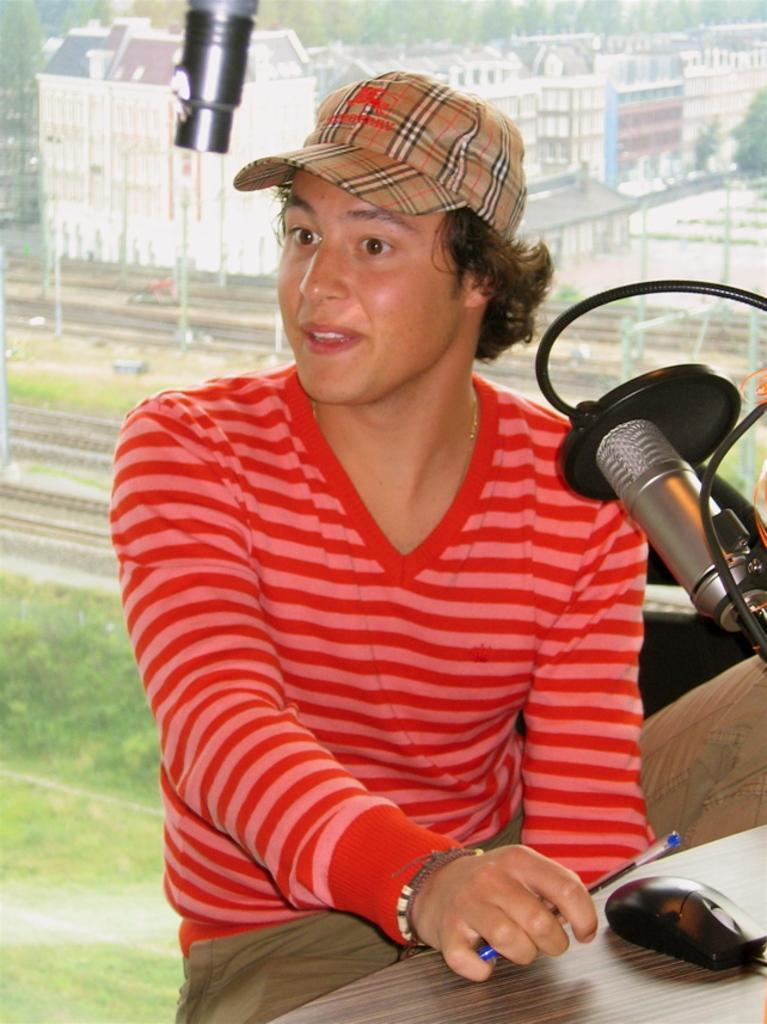Please provide a concise description of this image. In this image I can see a person wearing hat, red colored t shirt and pant is sitting in front of a desk and holding a pen. On the desk I can see a mouse and a microphone. I can see a glass surface behind the person through which I can see few trees, few railway tracks and few buildings. 